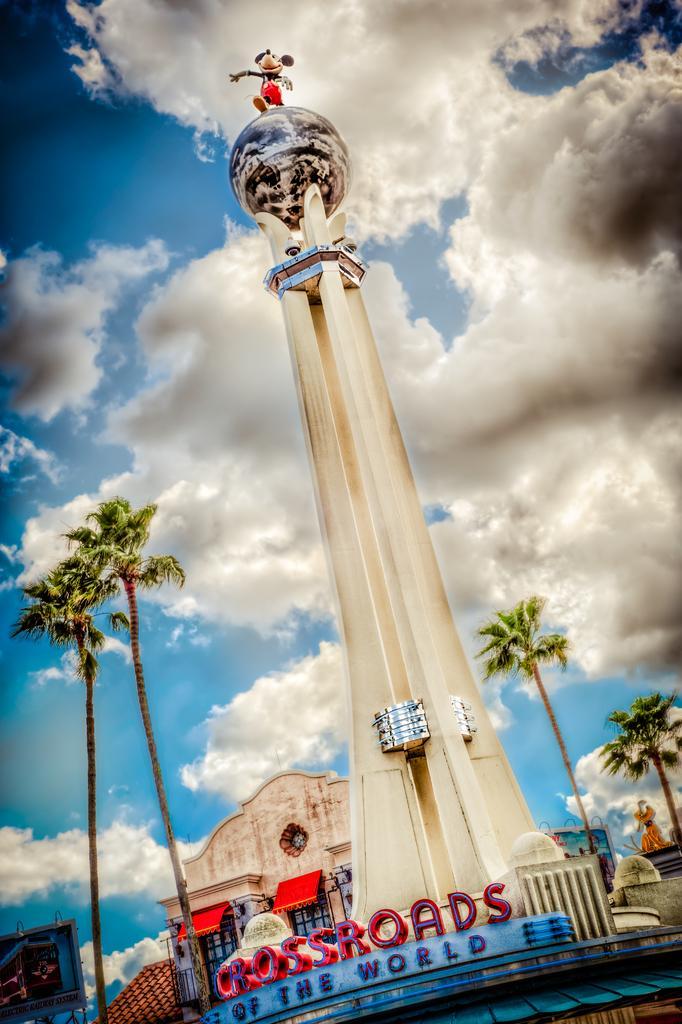In one or two sentences, can you explain what this image depicts? In the center of the image we can see a pillar. On the left side of the image we can see trees. In the background we can see trees, buildings, sky and clouds. 